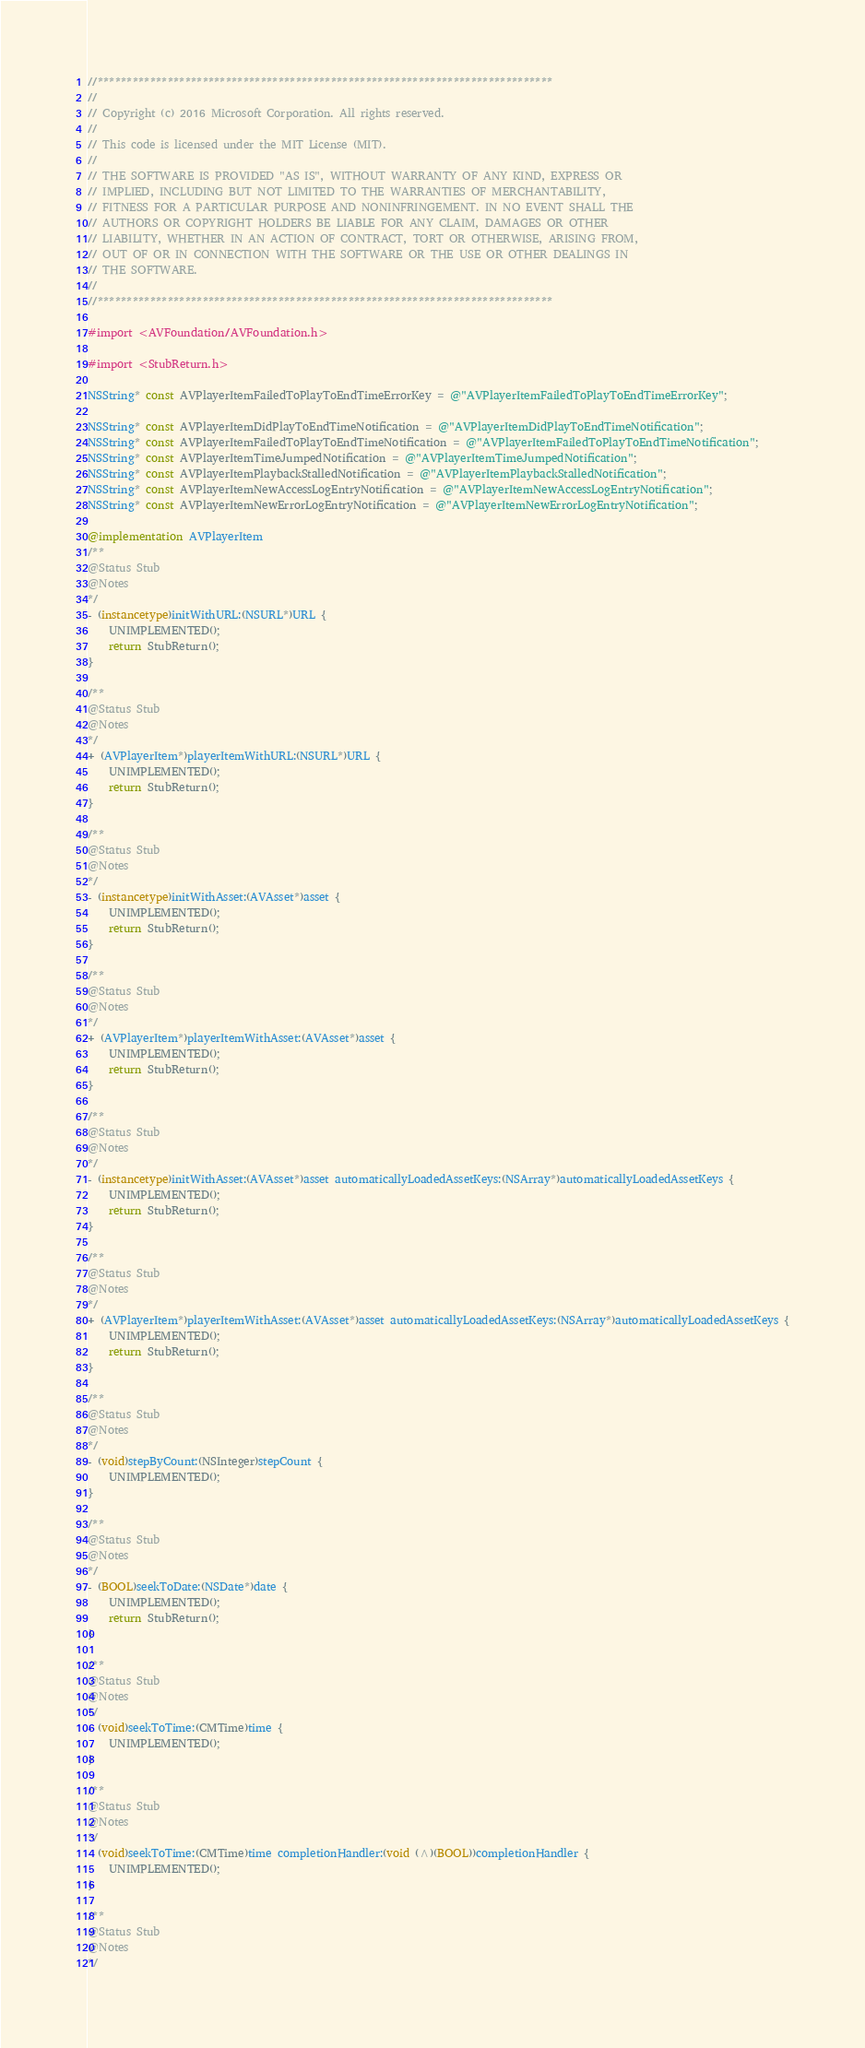<code> <loc_0><loc_0><loc_500><loc_500><_ObjectiveC_>//******************************************************************************
//
// Copyright (c) 2016 Microsoft Corporation. All rights reserved.
//
// This code is licensed under the MIT License (MIT).
//
// THE SOFTWARE IS PROVIDED "AS IS", WITHOUT WARRANTY OF ANY KIND, EXPRESS OR
// IMPLIED, INCLUDING BUT NOT LIMITED TO THE WARRANTIES OF MERCHANTABILITY,
// FITNESS FOR A PARTICULAR PURPOSE AND NONINFRINGEMENT. IN NO EVENT SHALL THE
// AUTHORS OR COPYRIGHT HOLDERS BE LIABLE FOR ANY CLAIM, DAMAGES OR OTHER
// LIABILITY, WHETHER IN AN ACTION OF CONTRACT, TORT OR OTHERWISE, ARISING FROM,
// OUT OF OR IN CONNECTION WITH THE SOFTWARE OR THE USE OR OTHER DEALINGS IN
// THE SOFTWARE.
//
//******************************************************************************

#import <AVFoundation/AVFoundation.h>

#import <StubReturn.h>

NSString* const AVPlayerItemFailedToPlayToEndTimeErrorKey = @"AVPlayerItemFailedToPlayToEndTimeErrorKey";

NSString* const AVPlayerItemDidPlayToEndTimeNotification = @"AVPlayerItemDidPlayToEndTimeNotification";
NSString* const AVPlayerItemFailedToPlayToEndTimeNotification = @"AVPlayerItemFailedToPlayToEndTimeNotification";
NSString* const AVPlayerItemTimeJumpedNotification = @"AVPlayerItemTimeJumpedNotification";
NSString* const AVPlayerItemPlaybackStalledNotification = @"AVPlayerItemPlaybackStalledNotification";
NSString* const AVPlayerItemNewAccessLogEntryNotification = @"AVPlayerItemNewAccessLogEntryNotification";
NSString* const AVPlayerItemNewErrorLogEntryNotification = @"AVPlayerItemNewErrorLogEntryNotification";

@implementation AVPlayerItem
/**
@Status Stub
@Notes
*/
- (instancetype)initWithURL:(NSURL*)URL {
    UNIMPLEMENTED();
    return StubReturn();
}

/**
@Status Stub
@Notes
*/
+ (AVPlayerItem*)playerItemWithURL:(NSURL*)URL {
    UNIMPLEMENTED();
    return StubReturn();
}

/**
@Status Stub
@Notes
*/
- (instancetype)initWithAsset:(AVAsset*)asset {
    UNIMPLEMENTED();
    return StubReturn();
}

/**
@Status Stub
@Notes
*/
+ (AVPlayerItem*)playerItemWithAsset:(AVAsset*)asset {
    UNIMPLEMENTED();
    return StubReturn();
}

/**
@Status Stub
@Notes
*/
- (instancetype)initWithAsset:(AVAsset*)asset automaticallyLoadedAssetKeys:(NSArray*)automaticallyLoadedAssetKeys {
    UNIMPLEMENTED();
    return StubReturn();
}

/**
@Status Stub
@Notes
*/
+ (AVPlayerItem*)playerItemWithAsset:(AVAsset*)asset automaticallyLoadedAssetKeys:(NSArray*)automaticallyLoadedAssetKeys {
    UNIMPLEMENTED();
    return StubReturn();
}

/**
@Status Stub
@Notes
*/
- (void)stepByCount:(NSInteger)stepCount {
    UNIMPLEMENTED();
}

/**
@Status Stub
@Notes
*/
- (BOOL)seekToDate:(NSDate*)date {
    UNIMPLEMENTED();
    return StubReturn();
}

/**
@Status Stub
@Notes
*/
- (void)seekToTime:(CMTime)time {
    UNIMPLEMENTED();
}

/**
@Status Stub
@Notes
*/
- (void)seekToTime:(CMTime)time completionHandler:(void (^)(BOOL))completionHandler {
    UNIMPLEMENTED();
}

/**
@Status Stub
@Notes
*/</code> 